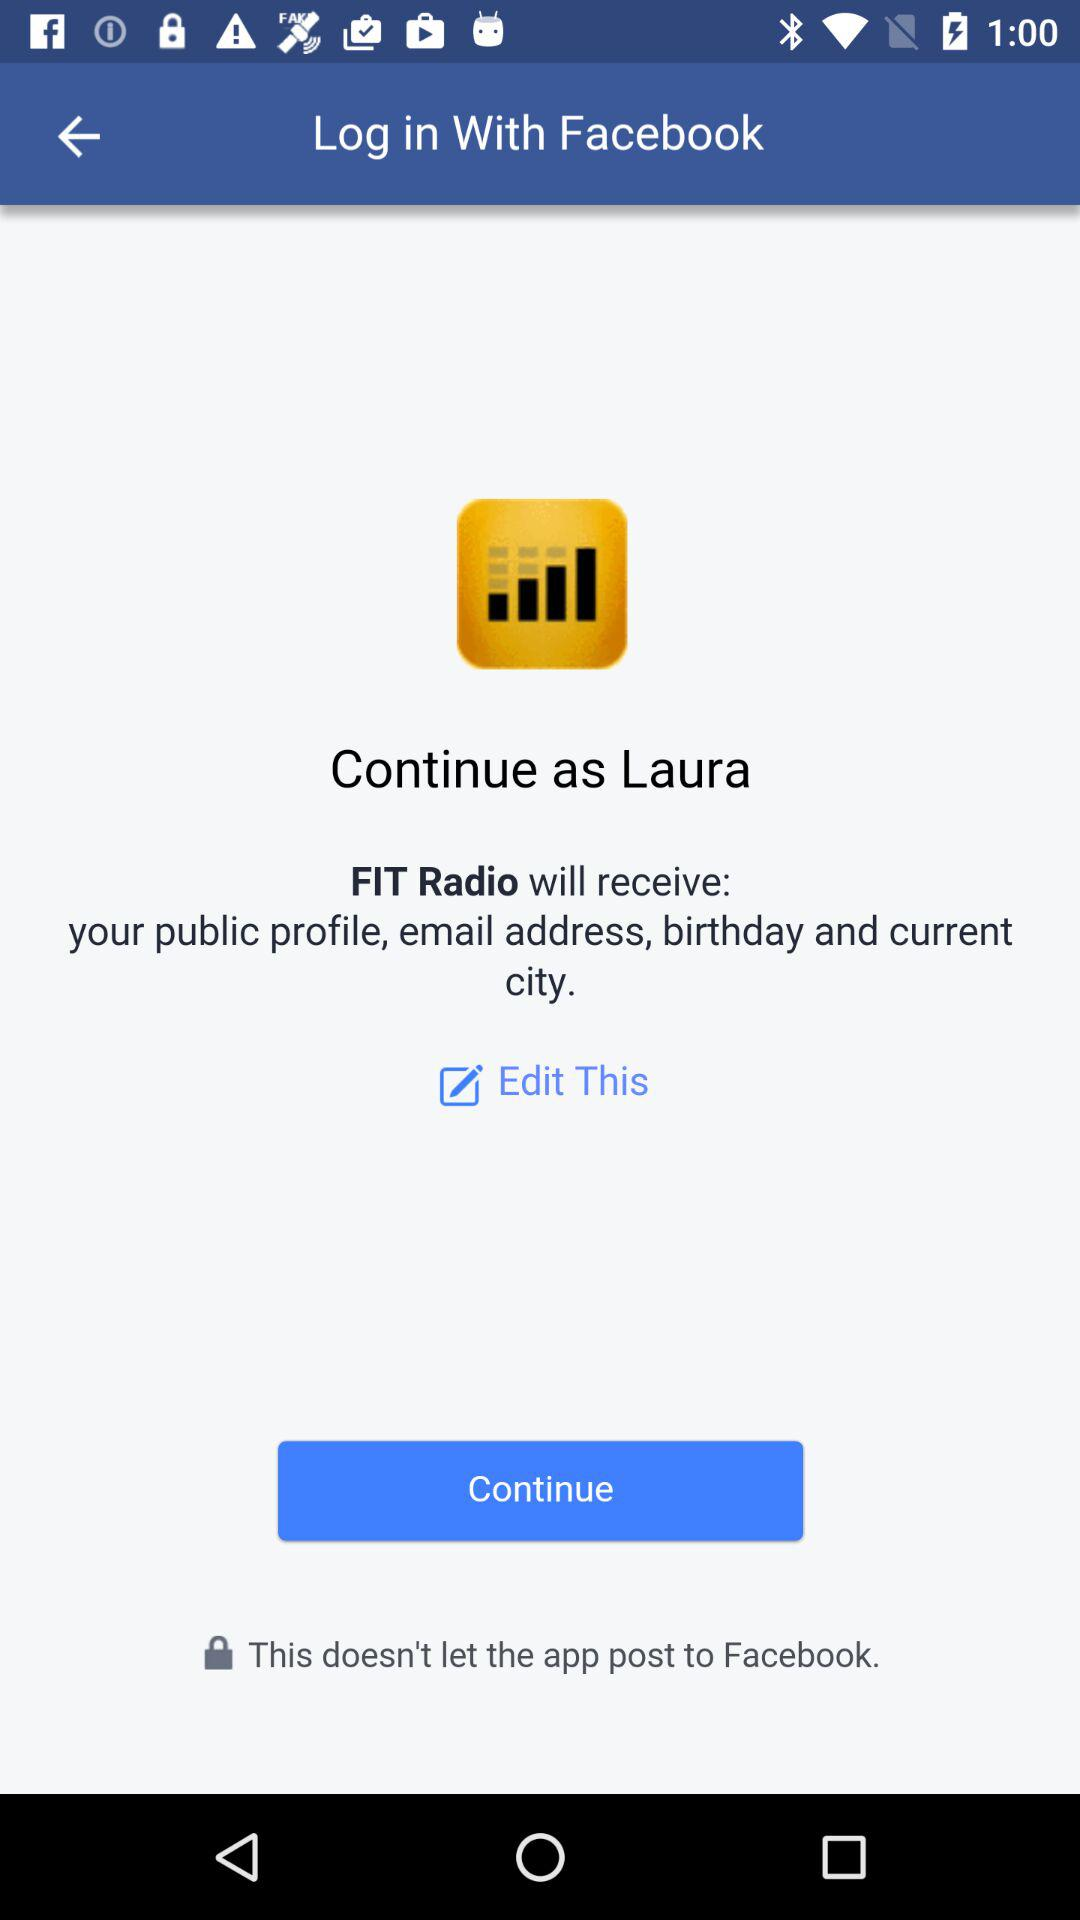What application is asking for permission? The application that is asking for permission is "FIT Radio". 